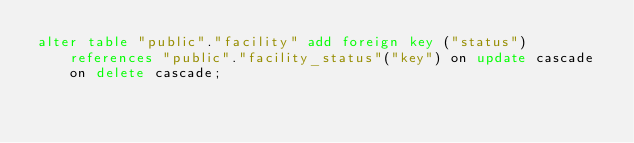<code> <loc_0><loc_0><loc_500><loc_500><_SQL_>alter table "public"."facility" add foreign key ("status") references "public"."facility_status"("key") on update cascade on delete cascade;
</code> 